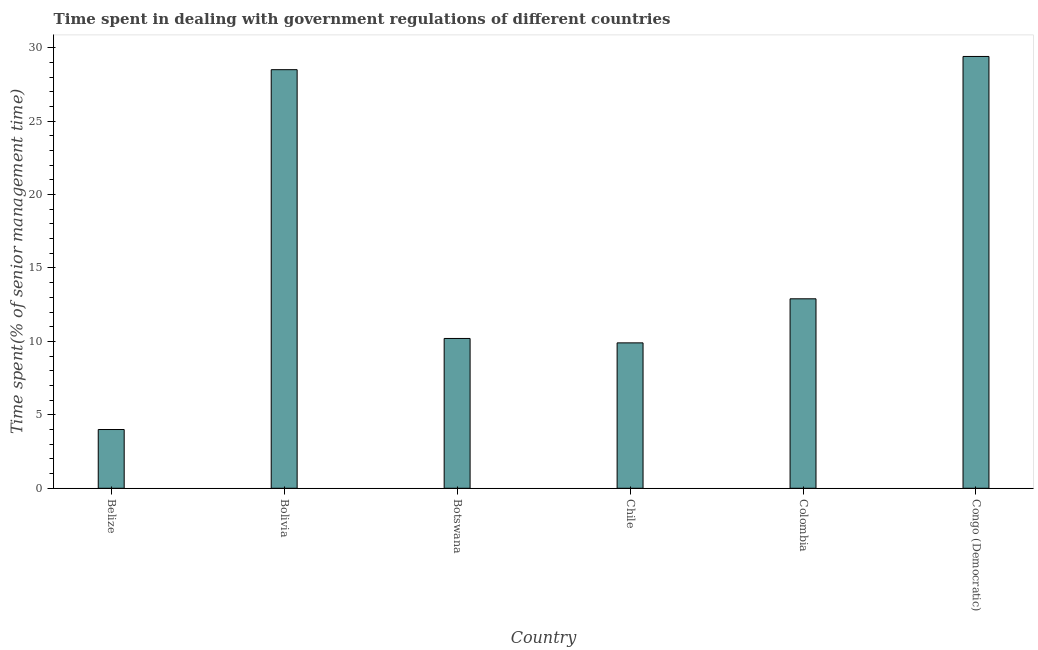Does the graph contain any zero values?
Your response must be concise. No. Does the graph contain grids?
Keep it short and to the point. No. What is the title of the graph?
Offer a very short reply. Time spent in dealing with government regulations of different countries. What is the label or title of the Y-axis?
Your answer should be very brief. Time spent(% of senior management time). What is the time spent in dealing with government regulations in Colombia?
Offer a very short reply. 12.9. Across all countries, what is the maximum time spent in dealing with government regulations?
Keep it short and to the point. 29.4. In which country was the time spent in dealing with government regulations maximum?
Provide a short and direct response. Congo (Democratic). In which country was the time spent in dealing with government regulations minimum?
Give a very brief answer. Belize. What is the sum of the time spent in dealing with government regulations?
Provide a succinct answer. 94.9. What is the difference between the time spent in dealing with government regulations in Chile and Congo (Democratic)?
Offer a terse response. -19.5. What is the average time spent in dealing with government regulations per country?
Your response must be concise. 15.82. What is the median time spent in dealing with government regulations?
Your answer should be very brief. 11.55. In how many countries, is the time spent in dealing with government regulations greater than 13 %?
Make the answer very short. 2. What is the ratio of the time spent in dealing with government regulations in Chile to that in Congo (Democratic)?
Provide a succinct answer. 0.34. What is the difference between the highest and the second highest time spent in dealing with government regulations?
Provide a short and direct response. 0.9. Is the sum of the time spent in dealing with government regulations in Colombia and Congo (Democratic) greater than the maximum time spent in dealing with government regulations across all countries?
Provide a succinct answer. Yes. What is the difference between the highest and the lowest time spent in dealing with government regulations?
Your answer should be very brief. 25.4. In how many countries, is the time spent in dealing with government regulations greater than the average time spent in dealing with government regulations taken over all countries?
Make the answer very short. 2. What is the difference between two consecutive major ticks on the Y-axis?
Provide a succinct answer. 5. Are the values on the major ticks of Y-axis written in scientific E-notation?
Keep it short and to the point. No. What is the Time spent(% of senior management time) in Belize?
Your response must be concise. 4. What is the Time spent(% of senior management time) in Botswana?
Provide a short and direct response. 10.2. What is the Time spent(% of senior management time) of Colombia?
Your answer should be compact. 12.9. What is the Time spent(% of senior management time) in Congo (Democratic)?
Your answer should be compact. 29.4. What is the difference between the Time spent(% of senior management time) in Belize and Bolivia?
Give a very brief answer. -24.5. What is the difference between the Time spent(% of senior management time) in Belize and Botswana?
Your answer should be very brief. -6.2. What is the difference between the Time spent(% of senior management time) in Belize and Chile?
Your answer should be very brief. -5.9. What is the difference between the Time spent(% of senior management time) in Belize and Congo (Democratic)?
Give a very brief answer. -25.4. What is the difference between the Time spent(% of senior management time) in Bolivia and Chile?
Offer a terse response. 18.6. What is the difference between the Time spent(% of senior management time) in Bolivia and Colombia?
Your response must be concise. 15.6. What is the difference between the Time spent(% of senior management time) in Bolivia and Congo (Democratic)?
Your answer should be very brief. -0.9. What is the difference between the Time spent(% of senior management time) in Botswana and Colombia?
Give a very brief answer. -2.7. What is the difference between the Time spent(% of senior management time) in Botswana and Congo (Democratic)?
Offer a very short reply. -19.2. What is the difference between the Time spent(% of senior management time) in Chile and Colombia?
Provide a short and direct response. -3. What is the difference between the Time spent(% of senior management time) in Chile and Congo (Democratic)?
Make the answer very short. -19.5. What is the difference between the Time spent(% of senior management time) in Colombia and Congo (Democratic)?
Make the answer very short. -16.5. What is the ratio of the Time spent(% of senior management time) in Belize to that in Bolivia?
Your answer should be very brief. 0.14. What is the ratio of the Time spent(% of senior management time) in Belize to that in Botswana?
Your answer should be compact. 0.39. What is the ratio of the Time spent(% of senior management time) in Belize to that in Chile?
Offer a terse response. 0.4. What is the ratio of the Time spent(% of senior management time) in Belize to that in Colombia?
Keep it short and to the point. 0.31. What is the ratio of the Time spent(% of senior management time) in Belize to that in Congo (Democratic)?
Provide a short and direct response. 0.14. What is the ratio of the Time spent(% of senior management time) in Bolivia to that in Botswana?
Offer a very short reply. 2.79. What is the ratio of the Time spent(% of senior management time) in Bolivia to that in Chile?
Give a very brief answer. 2.88. What is the ratio of the Time spent(% of senior management time) in Bolivia to that in Colombia?
Offer a very short reply. 2.21. What is the ratio of the Time spent(% of senior management time) in Bolivia to that in Congo (Democratic)?
Offer a terse response. 0.97. What is the ratio of the Time spent(% of senior management time) in Botswana to that in Chile?
Ensure brevity in your answer.  1.03. What is the ratio of the Time spent(% of senior management time) in Botswana to that in Colombia?
Offer a terse response. 0.79. What is the ratio of the Time spent(% of senior management time) in Botswana to that in Congo (Democratic)?
Your answer should be very brief. 0.35. What is the ratio of the Time spent(% of senior management time) in Chile to that in Colombia?
Your answer should be very brief. 0.77. What is the ratio of the Time spent(% of senior management time) in Chile to that in Congo (Democratic)?
Keep it short and to the point. 0.34. What is the ratio of the Time spent(% of senior management time) in Colombia to that in Congo (Democratic)?
Your answer should be compact. 0.44. 